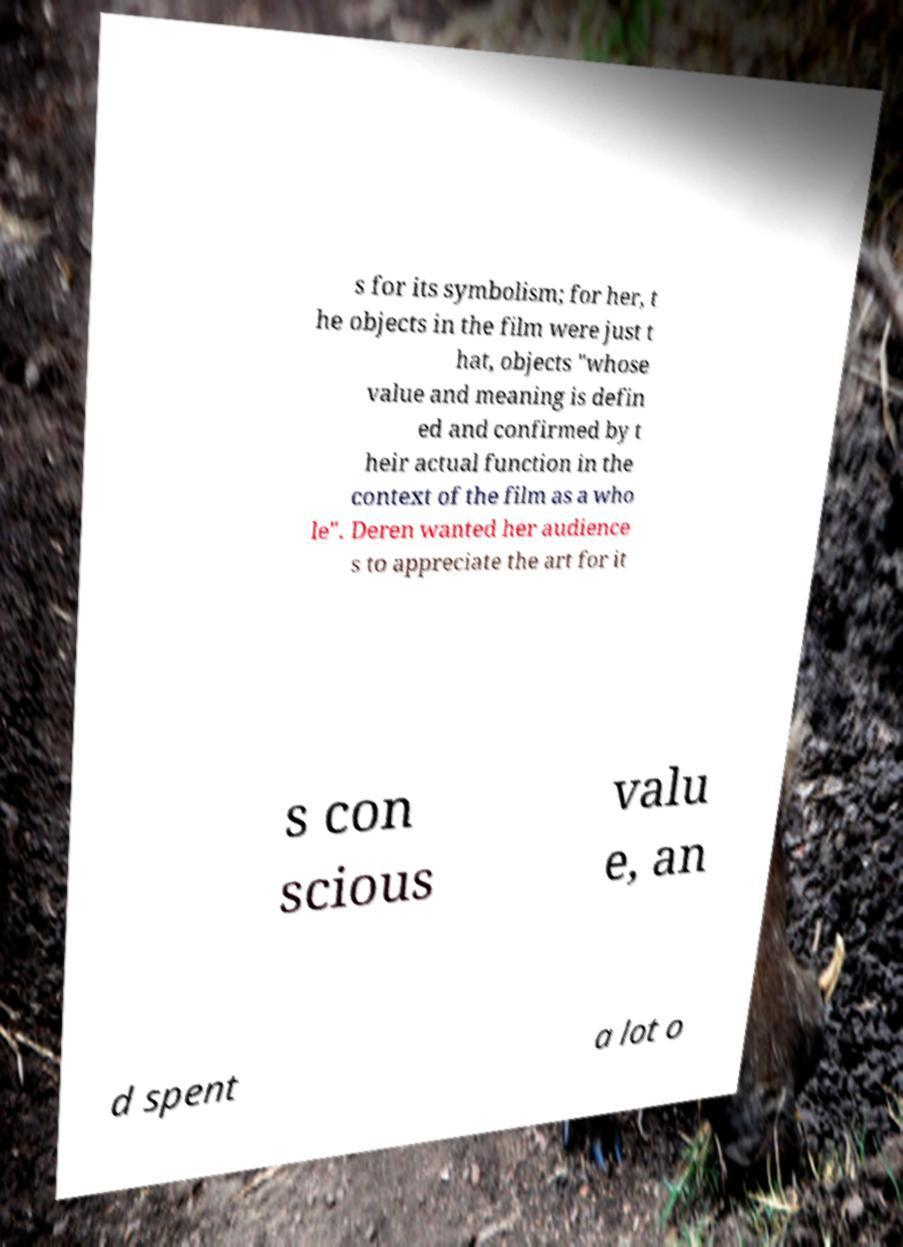Could you extract and type out the text from this image? s for its symbolism; for her, t he objects in the film were just t hat, objects "whose value and meaning is defin ed and confirmed by t heir actual function in the context of the film as a who le". Deren wanted her audience s to appreciate the art for it s con scious valu e, an d spent a lot o 